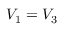Convert formula to latex. <formula><loc_0><loc_0><loc_500><loc_500>V _ { 1 } = V _ { 3 }</formula> 